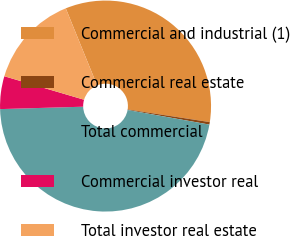Convert chart to OTSL. <chart><loc_0><loc_0><loc_500><loc_500><pie_chart><fcel>Commercial and industrial (1)<fcel>Commercial real estate<fcel>Total commercial<fcel>Commercial investor real<fcel>Total investor real estate<nl><fcel>33.58%<fcel>0.38%<fcel>46.73%<fcel>5.02%<fcel>14.29%<nl></chart> 